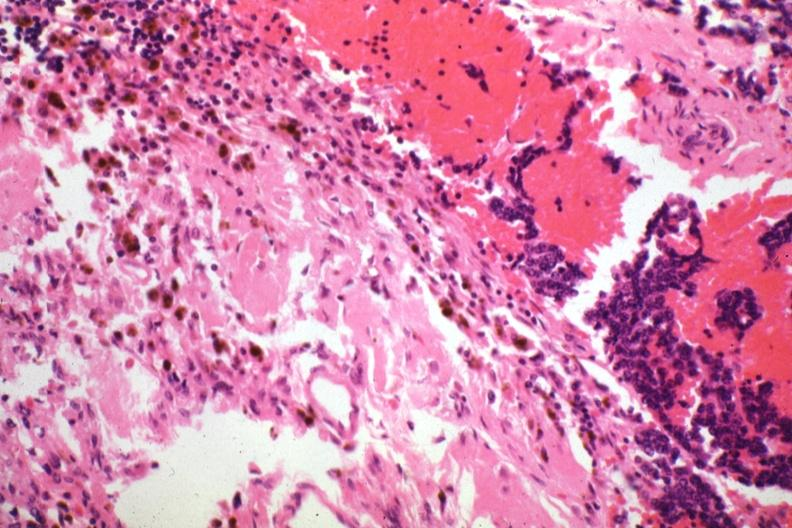s pituitary present?
Answer the question using a single word or phrase. Yes 